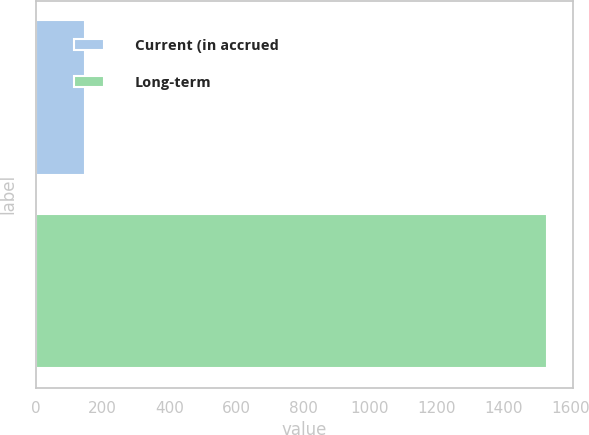<chart> <loc_0><loc_0><loc_500><loc_500><bar_chart><fcel>Current (in accrued<fcel>Long-term<nl><fcel>147<fcel>1531<nl></chart> 